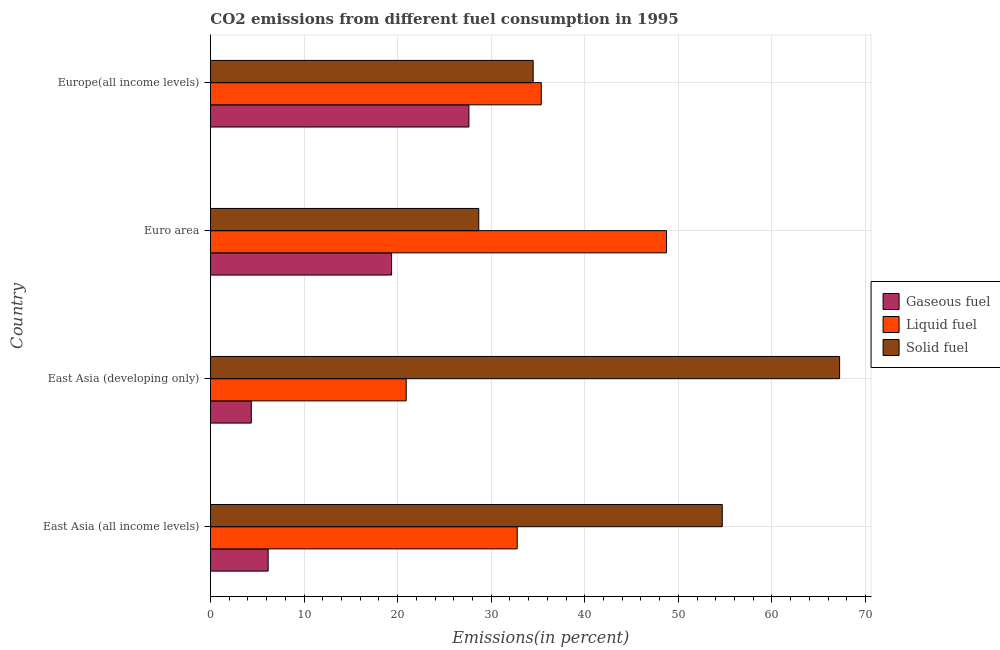Are the number of bars per tick equal to the number of legend labels?
Give a very brief answer. Yes. How many bars are there on the 3rd tick from the top?
Give a very brief answer. 3. What is the label of the 1st group of bars from the top?
Your answer should be very brief. Europe(all income levels). What is the percentage of solid fuel emission in East Asia (developing only)?
Your answer should be compact. 67.23. Across all countries, what is the maximum percentage of liquid fuel emission?
Provide a short and direct response. 48.73. Across all countries, what is the minimum percentage of liquid fuel emission?
Your response must be concise. 20.92. In which country was the percentage of solid fuel emission maximum?
Ensure brevity in your answer.  East Asia (developing only). In which country was the percentage of gaseous fuel emission minimum?
Your answer should be compact. East Asia (developing only). What is the total percentage of solid fuel emission in the graph?
Offer a very short reply. 185.08. What is the difference between the percentage of solid fuel emission in East Asia (all income levels) and that in Euro area?
Provide a succinct answer. 26.02. What is the difference between the percentage of solid fuel emission in Euro area and the percentage of liquid fuel emission in Europe(all income levels)?
Ensure brevity in your answer.  -6.68. What is the average percentage of solid fuel emission per country?
Provide a succinct answer. 46.27. What is the difference between the percentage of gaseous fuel emission and percentage of solid fuel emission in East Asia (developing only)?
Offer a very short reply. -62.87. In how many countries, is the percentage of liquid fuel emission greater than 12 %?
Give a very brief answer. 4. What is the ratio of the percentage of liquid fuel emission in East Asia (all income levels) to that in East Asia (developing only)?
Your answer should be very brief. 1.57. Is the percentage of gaseous fuel emission in Euro area less than that in Europe(all income levels)?
Your response must be concise. Yes. Is the difference between the percentage of solid fuel emission in Euro area and Europe(all income levels) greater than the difference between the percentage of gaseous fuel emission in Euro area and Europe(all income levels)?
Offer a very short reply. Yes. What is the difference between the highest and the second highest percentage of liquid fuel emission?
Your response must be concise. 13.38. What is the difference between the highest and the lowest percentage of gaseous fuel emission?
Provide a succinct answer. 23.26. In how many countries, is the percentage of liquid fuel emission greater than the average percentage of liquid fuel emission taken over all countries?
Ensure brevity in your answer.  2. Is the sum of the percentage of liquid fuel emission in East Asia (all income levels) and East Asia (developing only) greater than the maximum percentage of solid fuel emission across all countries?
Your response must be concise. No. What does the 3rd bar from the top in Europe(all income levels) represents?
Give a very brief answer. Gaseous fuel. What does the 2nd bar from the bottom in Euro area represents?
Your answer should be compact. Liquid fuel. Is it the case that in every country, the sum of the percentage of gaseous fuel emission and percentage of liquid fuel emission is greater than the percentage of solid fuel emission?
Keep it short and to the point. No. How many bars are there?
Your response must be concise. 12. Are all the bars in the graph horizontal?
Offer a very short reply. Yes. What is the difference between two consecutive major ticks on the X-axis?
Offer a very short reply. 10. Are the values on the major ticks of X-axis written in scientific E-notation?
Provide a succinct answer. No. Does the graph contain any zero values?
Ensure brevity in your answer.  No. Where does the legend appear in the graph?
Your answer should be compact. Center right. How many legend labels are there?
Give a very brief answer. 3. How are the legend labels stacked?
Give a very brief answer. Vertical. What is the title of the graph?
Provide a succinct answer. CO2 emissions from different fuel consumption in 1995. Does "Industrial Nitrous Oxide" appear as one of the legend labels in the graph?
Make the answer very short. No. What is the label or title of the X-axis?
Offer a terse response. Emissions(in percent). What is the label or title of the Y-axis?
Give a very brief answer. Country. What is the Emissions(in percent) in Gaseous fuel in East Asia (all income levels)?
Offer a very short reply. 6.16. What is the Emissions(in percent) in Liquid fuel in East Asia (all income levels)?
Your answer should be compact. 32.78. What is the Emissions(in percent) of Solid fuel in East Asia (all income levels)?
Make the answer very short. 54.69. What is the Emissions(in percent) of Gaseous fuel in East Asia (developing only)?
Your answer should be compact. 4.36. What is the Emissions(in percent) of Liquid fuel in East Asia (developing only)?
Your answer should be very brief. 20.92. What is the Emissions(in percent) of Solid fuel in East Asia (developing only)?
Ensure brevity in your answer.  67.23. What is the Emissions(in percent) in Gaseous fuel in Euro area?
Make the answer very short. 19.35. What is the Emissions(in percent) in Liquid fuel in Euro area?
Provide a short and direct response. 48.73. What is the Emissions(in percent) in Solid fuel in Euro area?
Provide a short and direct response. 28.67. What is the Emissions(in percent) in Gaseous fuel in Europe(all income levels)?
Offer a very short reply. 27.62. What is the Emissions(in percent) in Liquid fuel in Europe(all income levels)?
Your answer should be compact. 35.35. What is the Emissions(in percent) in Solid fuel in Europe(all income levels)?
Provide a short and direct response. 34.48. Across all countries, what is the maximum Emissions(in percent) of Gaseous fuel?
Your response must be concise. 27.62. Across all countries, what is the maximum Emissions(in percent) of Liquid fuel?
Your answer should be very brief. 48.73. Across all countries, what is the maximum Emissions(in percent) of Solid fuel?
Offer a very short reply. 67.23. Across all countries, what is the minimum Emissions(in percent) in Gaseous fuel?
Offer a very short reply. 4.36. Across all countries, what is the minimum Emissions(in percent) in Liquid fuel?
Provide a short and direct response. 20.92. Across all countries, what is the minimum Emissions(in percent) in Solid fuel?
Offer a very short reply. 28.67. What is the total Emissions(in percent) in Gaseous fuel in the graph?
Ensure brevity in your answer.  57.5. What is the total Emissions(in percent) in Liquid fuel in the graph?
Offer a very short reply. 137.78. What is the total Emissions(in percent) in Solid fuel in the graph?
Your answer should be very brief. 185.08. What is the difference between the Emissions(in percent) of Gaseous fuel in East Asia (all income levels) and that in East Asia (developing only)?
Keep it short and to the point. 1.8. What is the difference between the Emissions(in percent) of Liquid fuel in East Asia (all income levels) and that in East Asia (developing only)?
Your response must be concise. 11.86. What is the difference between the Emissions(in percent) of Solid fuel in East Asia (all income levels) and that in East Asia (developing only)?
Provide a short and direct response. -12.54. What is the difference between the Emissions(in percent) of Gaseous fuel in East Asia (all income levels) and that in Euro area?
Provide a succinct answer. -13.19. What is the difference between the Emissions(in percent) in Liquid fuel in East Asia (all income levels) and that in Euro area?
Offer a terse response. -15.95. What is the difference between the Emissions(in percent) in Solid fuel in East Asia (all income levels) and that in Euro area?
Offer a terse response. 26.02. What is the difference between the Emissions(in percent) of Gaseous fuel in East Asia (all income levels) and that in Europe(all income levels)?
Your answer should be very brief. -21.46. What is the difference between the Emissions(in percent) in Liquid fuel in East Asia (all income levels) and that in Europe(all income levels)?
Make the answer very short. -2.57. What is the difference between the Emissions(in percent) in Solid fuel in East Asia (all income levels) and that in Europe(all income levels)?
Offer a very short reply. 20.21. What is the difference between the Emissions(in percent) in Gaseous fuel in East Asia (developing only) and that in Euro area?
Your answer should be compact. -14.99. What is the difference between the Emissions(in percent) of Liquid fuel in East Asia (developing only) and that in Euro area?
Give a very brief answer. -27.81. What is the difference between the Emissions(in percent) in Solid fuel in East Asia (developing only) and that in Euro area?
Your answer should be very brief. 38.56. What is the difference between the Emissions(in percent) in Gaseous fuel in East Asia (developing only) and that in Europe(all income levels)?
Your answer should be very brief. -23.26. What is the difference between the Emissions(in percent) in Liquid fuel in East Asia (developing only) and that in Europe(all income levels)?
Provide a short and direct response. -14.43. What is the difference between the Emissions(in percent) of Solid fuel in East Asia (developing only) and that in Europe(all income levels)?
Your answer should be compact. 32.75. What is the difference between the Emissions(in percent) in Gaseous fuel in Euro area and that in Europe(all income levels)?
Make the answer very short. -8.27. What is the difference between the Emissions(in percent) in Liquid fuel in Euro area and that in Europe(all income levels)?
Offer a terse response. 13.38. What is the difference between the Emissions(in percent) in Solid fuel in Euro area and that in Europe(all income levels)?
Keep it short and to the point. -5.81. What is the difference between the Emissions(in percent) in Gaseous fuel in East Asia (all income levels) and the Emissions(in percent) in Liquid fuel in East Asia (developing only)?
Provide a succinct answer. -14.75. What is the difference between the Emissions(in percent) in Gaseous fuel in East Asia (all income levels) and the Emissions(in percent) in Solid fuel in East Asia (developing only)?
Your answer should be compact. -61.07. What is the difference between the Emissions(in percent) of Liquid fuel in East Asia (all income levels) and the Emissions(in percent) of Solid fuel in East Asia (developing only)?
Provide a succinct answer. -34.45. What is the difference between the Emissions(in percent) in Gaseous fuel in East Asia (all income levels) and the Emissions(in percent) in Liquid fuel in Euro area?
Your response must be concise. -42.57. What is the difference between the Emissions(in percent) of Gaseous fuel in East Asia (all income levels) and the Emissions(in percent) of Solid fuel in Euro area?
Make the answer very short. -22.51. What is the difference between the Emissions(in percent) in Liquid fuel in East Asia (all income levels) and the Emissions(in percent) in Solid fuel in Euro area?
Give a very brief answer. 4.11. What is the difference between the Emissions(in percent) of Gaseous fuel in East Asia (all income levels) and the Emissions(in percent) of Liquid fuel in Europe(all income levels)?
Your response must be concise. -29.19. What is the difference between the Emissions(in percent) in Gaseous fuel in East Asia (all income levels) and the Emissions(in percent) in Solid fuel in Europe(all income levels)?
Keep it short and to the point. -28.32. What is the difference between the Emissions(in percent) of Liquid fuel in East Asia (all income levels) and the Emissions(in percent) of Solid fuel in Europe(all income levels)?
Provide a succinct answer. -1.71. What is the difference between the Emissions(in percent) of Gaseous fuel in East Asia (developing only) and the Emissions(in percent) of Liquid fuel in Euro area?
Make the answer very short. -44.37. What is the difference between the Emissions(in percent) of Gaseous fuel in East Asia (developing only) and the Emissions(in percent) of Solid fuel in Euro area?
Give a very brief answer. -24.31. What is the difference between the Emissions(in percent) of Liquid fuel in East Asia (developing only) and the Emissions(in percent) of Solid fuel in Euro area?
Make the answer very short. -7.75. What is the difference between the Emissions(in percent) in Gaseous fuel in East Asia (developing only) and the Emissions(in percent) in Liquid fuel in Europe(all income levels)?
Your answer should be very brief. -30.99. What is the difference between the Emissions(in percent) in Gaseous fuel in East Asia (developing only) and the Emissions(in percent) in Solid fuel in Europe(all income levels)?
Provide a short and direct response. -30.12. What is the difference between the Emissions(in percent) in Liquid fuel in East Asia (developing only) and the Emissions(in percent) in Solid fuel in Europe(all income levels)?
Give a very brief answer. -13.57. What is the difference between the Emissions(in percent) of Gaseous fuel in Euro area and the Emissions(in percent) of Liquid fuel in Europe(all income levels)?
Your answer should be very brief. -16. What is the difference between the Emissions(in percent) in Gaseous fuel in Euro area and the Emissions(in percent) in Solid fuel in Europe(all income levels)?
Offer a very short reply. -15.13. What is the difference between the Emissions(in percent) of Liquid fuel in Euro area and the Emissions(in percent) of Solid fuel in Europe(all income levels)?
Your response must be concise. 14.25. What is the average Emissions(in percent) in Gaseous fuel per country?
Make the answer very short. 14.37. What is the average Emissions(in percent) of Liquid fuel per country?
Your answer should be compact. 34.44. What is the average Emissions(in percent) of Solid fuel per country?
Your response must be concise. 46.27. What is the difference between the Emissions(in percent) of Gaseous fuel and Emissions(in percent) of Liquid fuel in East Asia (all income levels)?
Provide a succinct answer. -26.62. What is the difference between the Emissions(in percent) of Gaseous fuel and Emissions(in percent) of Solid fuel in East Asia (all income levels)?
Give a very brief answer. -48.53. What is the difference between the Emissions(in percent) in Liquid fuel and Emissions(in percent) in Solid fuel in East Asia (all income levels)?
Offer a terse response. -21.91. What is the difference between the Emissions(in percent) of Gaseous fuel and Emissions(in percent) of Liquid fuel in East Asia (developing only)?
Offer a terse response. -16.56. What is the difference between the Emissions(in percent) of Gaseous fuel and Emissions(in percent) of Solid fuel in East Asia (developing only)?
Your answer should be compact. -62.87. What is the difference between the Emissions(in percent) in Liquid fuel and Emissions(in percent) in Solid fuel in East Asia (developing only)?
Give a very brief answer. -46.32. What is the difference between the Emissions(in percent) of Gaseous fuel and Emissions(in percent) of Liquid fuel in Euro area?
Your answer should be compact. -29.38. What is the difference between the Emissions(in percent) in Gaseous fuel and Emissions(in percent) in Solid fuel in Euro area?
Provide a succinct answer. -9.32. What is the difference between the Emissions(in percent) in Liquid fuel and Emissions(in percent) in Solid fuel in Euro area?
Keep it short and to the point. 20.06. What is the difference between the Emissions(in percent) of Gaseous fuel and Emissions(in percent) of Liquid fuel in Europe(all income levels)?
Offer a very short reply. -7.73. What is the difference between the Emissions(in percent) in Gaseous fuel and Emissions(in percent) in Solid fuel in Europe(all income levels)?
Your answer should be very brief. -6.87. What is the difference between the Emissions(in percent) in Liquid fuel and Emissions(in percent) in Solid fuel in Europe(all income levels)?
Make the answer very short. 0.87. What is the ratio of the Emissions(in percent) of Gaseous fuel in East Asia (all income levels) to that in East Asia (developing only)?
Offer a terse response. 1.41. What is the ratio of the Emissions(in percent) in Liquid fuel in East Asia (all income levels) to that in East Asia (developing only)?
Give a very brief answer. 1.57. What is the ratio of the Emissions(in percent) of Solid fuel in East Asia (all income levels) to that in East Asia (developing only)?
Ensure brevity in your answer.  0.81. What is the ratio of the Emissions(in percent) in Gaseous fuel in East Asia (all income levels) to that in Euro area?
Provide a short and direct response. 0.32. What is the ratio of the Emissions(in percent) in Liquid fuel in East Asia (all income levels) to that in Euro area?
Offer a terse response. 0.67. What is the ratio of the Emissions(in percent) of Solid fuel in East Asia (all income levels) to that in Euro area?
Your response must be concise. 1.91. What is the ratio of the Emissions(in percent) in Gaseous fuel in East Asia (all income levels) to that in Europe(all income levels)?
Offer a terse response. 0.22. What is the ratio of the Emissions(in percent) in Liquid fuel in East Asia (all income levels) to that in Europe(all income levels)?
Offer a very short reply. 0.93. What is the ratio of the Emissions(in percent) in Solid fuel in East Asia (all income levels) to that in Europe(all income levels)?
Offer a terse response. 1.59. What is the ratio of the Emissions(in percent) in Gaseous fuel in East Asia (developing only) to that in Euro area?
Ensure brevity in your answer.  0.23. What is the ratio of the Emissions(in percent) of Liquid fuel in East Asia (developing only) to that in Euro area?
Provide a succinct answer. 0.43. What is the ratio of the Emissions(in percent) of Solid fuel in East Asia (developing only) to that in Euro area?
Your answer should be very brief. 2.35. What is the ratio of the Emissions(in percent) in Gaseous fuel in East Asia (developing only) to that in Europe(all income levels)?
Provide a succinct answer. 0.16. What is the ratio of the Emissions(in percent) of Liquid fuel in East Asia (developing only) to that in Europe(all income levels)?
Offer a terse response. 0.59. What is the ratio of the Emissions(in percent) of Solid fuel in East Asia (developing only) to that in Europe(all income levels)?
Your answer should be compact. 1.95. What is the ratio of the Emissions(in percent) in Gaseous fuel in Euro area to that in Europe(all income levels)?
Keep it short and to the point. 0.7. What is the ratio of the Emissions(in percent) of Liquid fuel in Euro area to that in Europe(all income levels)?
Your response must be concise. 1.38. What is the ratio of the Emissions(in percent) in Solid fuel in Euro area to that in Europe(all income levels)?
Give a very brief answer. 0.83. What is the difference between the highest and the second highest Emissions(in percent) in Gaseous fuel?
Offer a terse response. 8.27. What is the difference between the highest and the second highest Emissions(in percent) in Liquid fuel?
Ensure brevity in your answer.  13.38. What is the difference between the highest and the second highest Emissions(in percent) of Solid fuel?
Provide a succinct answer. 12.54. What is the difference between the highest and the lowest Emissions(in percent) in Gaseous fuel?
Provide a succinct answer. 23.26. What is the difference between the highest and the lowest Emissions(in percent) in Liquid fuel?
Offer a very short reply. 27.81. What is the difference between the highest and the lowest Emissions(in percent) of Solid fuel?
Offer a very short reply. 38.56. 